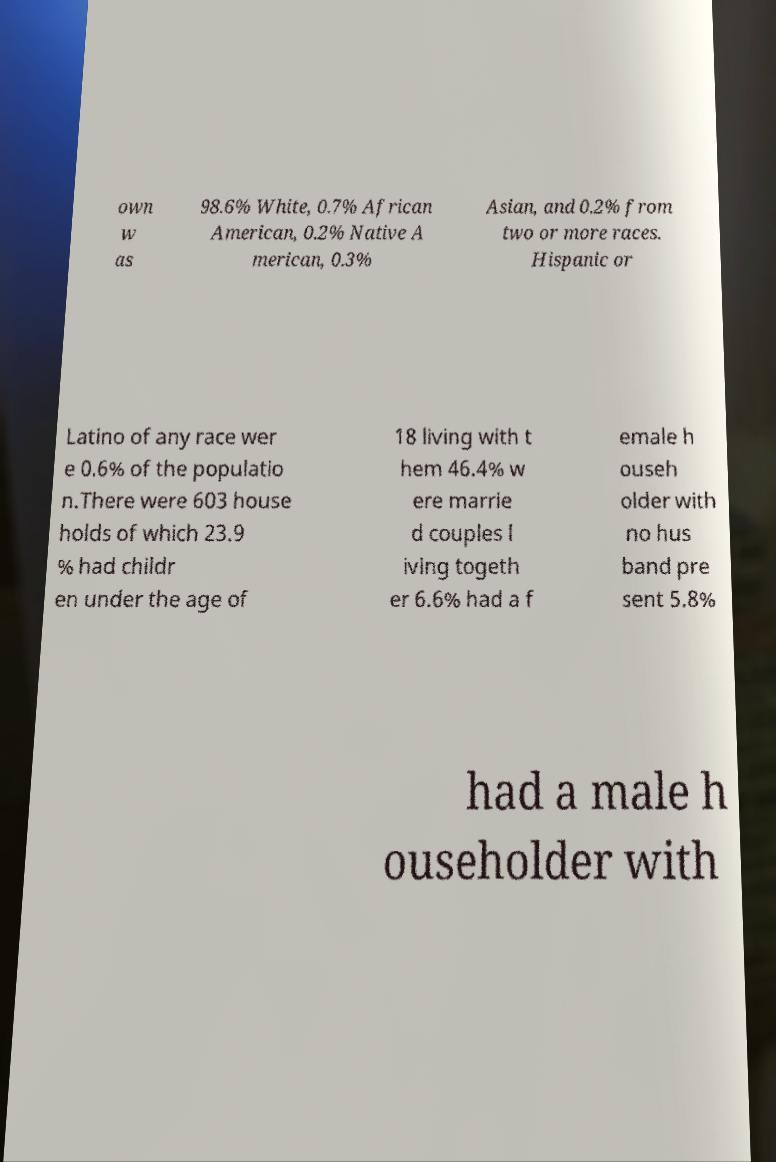Can you accurately transcribe the text from the provided image for me? own w as 98.6% White, 0.7% African American, 0.2% Native A merican, 0.3% Asian, and 0.2% from two or more races. Hispanic or Latino of any race wer e 0.6% of the populatio n.There were 603 house holds of which 23.9 % had childr en under the age of 18 living with t hem 46.4% w ere marrie d couples l iving togeth er 6.6% had a f emale h ouseh older with no hus band pre sent 5.8% had a male h ouseholder with 